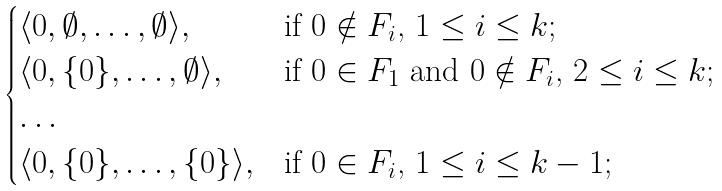<formula> <loc_0><loc_0><loc_500><loc_500>\begin{cases} \langle 0 , \emptyset , \dots , \emptyset \rangle , & \text {if $0\notin F_{i}$, $1\leq i\leq k$} ; \\ \langle 0 , \{ 0 \} , \dots , \emptyset \rangle , & \text {if $0 \in F_{1}$ and $0\notin F_{i}$, $2\leq i\leq k$} ; \\ \dots & \\ \langle 0 , \{ 0 \} , \dots , \{ 0 \} \rangle , & \text {if $0 \in F_{i}$, $1\leq i\leq k-1$} ; \end{cases}</formula> 